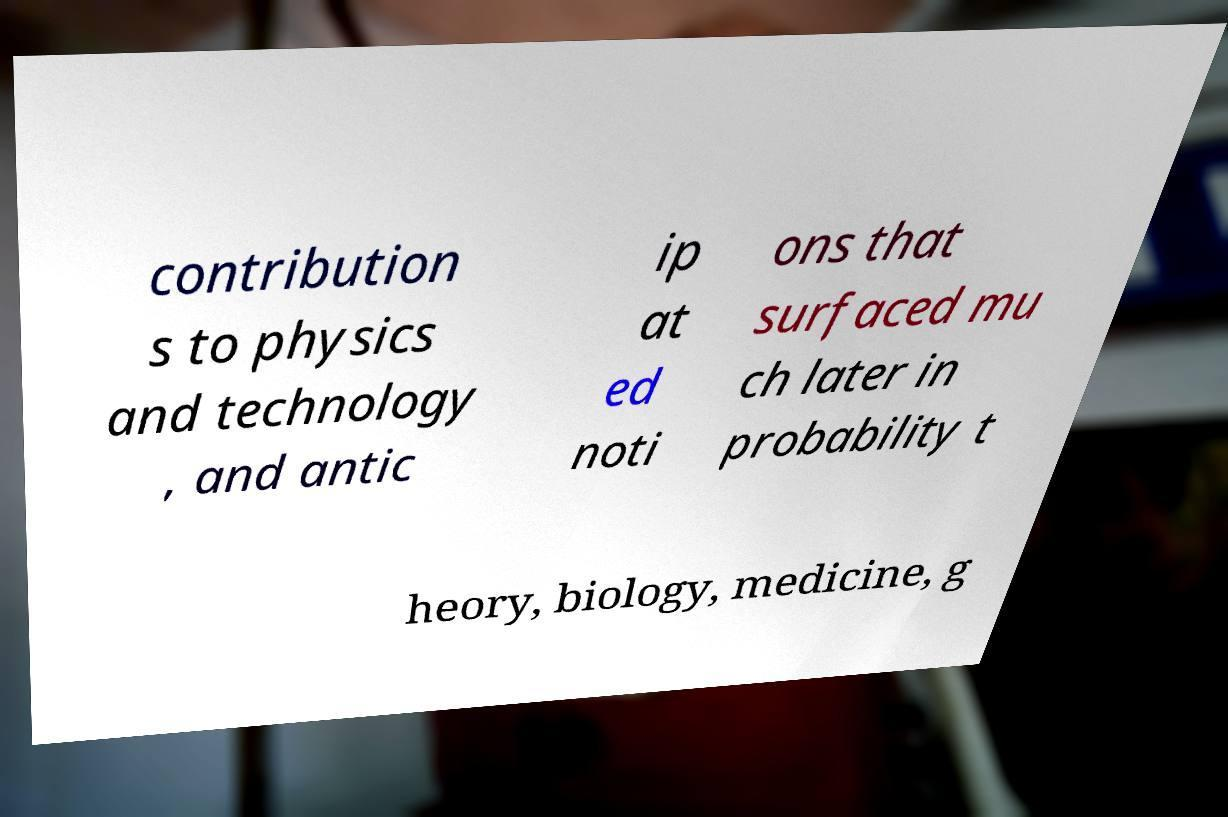There's text embedded in this image that I need extracted. Can you transcribe it verbatim? contribution s to physics and technology , and antic ip at ed noti ons that surfaced mu ch later in probability t heory, biology, medicine, g 